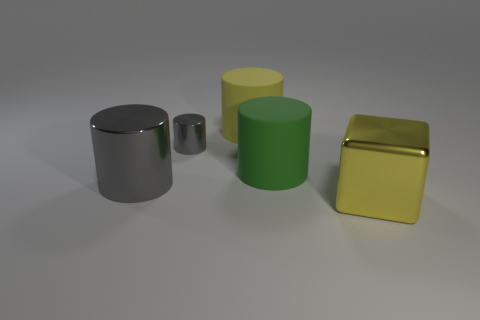The tiny gray thing has what shape?
Ensure brevity in your answer.  Cylinder. What is the material of the big cylinder behind the metal thing that is behind the cylinder that is in front of the green object?
Your answer should be compact. Rubber. There is a large cylinder that is the same color as the big metallic cube; what is its material?
Offer a very short reply. Rubber. What number of objects are large gray cylinders or yellow rubber cylinders?
Provide a short and direct response. 2. Does the large yellow thing on the left side of the yellow metallic thing have the same material as the small gray object?
Provide a succinct answer. No. How many things are gray metal objects in front of the tiny cylinder or small brown shiny balls?
Make the answer very short. 1. What is the color of the cube that is the same material as the tiny gray thing?
Offer a very short reply. Yellow. Is there a green ball of the same size as the yellow matte object?
Offer a very short reply. No. Do the large cylinder in front of the large green matte cylinder and the large cube have the same color?
Give a very brief answer. No. What color is the thing that is both in front of the big green cylinder and to the right of the yellow rubber object?
Your response must be concise. Yellow. 